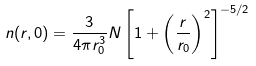Convert formula to latex. <formula><loc_0><loc_0><loc_500><loc_500>n ( r , 0 ) = \frac { 3 } { 4 \pi r _ { 0 } ^ { 3 } } N \left [ 1 + \left ( \frac { r } { r _ { 0 } } \right ) ^ { 2 } \right ] ^ { - 5 / 2 }</formula> 